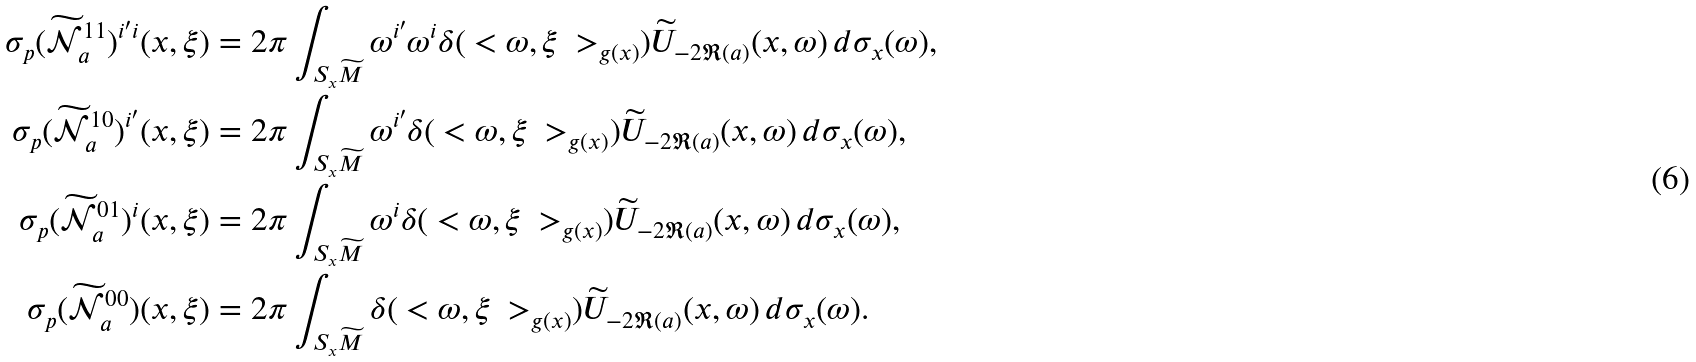Convert formula to latex. <formula><loc_0><loc_0><loc_500><loc_500>\sigma _ { p } ( \widetilde { \mathcal { N } } _ { a } ^ { 1 1 } ) ^ { i ^ { \prime } i } ( x , \xi ) & = 2 \pi \int _ { S _ { x } \widetilde { M } } \omega ^ { i ^ { \prime } } \omega ^ { i } \delta ( \ < \omega , \xi \ > _ { g ( x ) } ) \widetilde { U } _ { - 2 \Re ( a ) } ( x , \omega ) \, d \sigma _ { x } ( \omega ) , \\ \sigma _ { p } ( \widetilde { \mathcal { N } } _ { a } ^ { 1 0 } ) ^ { i ^ { \prime } } ( x , \xi ) & = 2 \pi \int _ { S _ { x } \widetilde { M } } \omega ^ { i ^ { \prime } } \delta ( \ < \omega , \xi \ > _ { g ( x ) } ) \widetilde { U } _ { - 2 \Re ( a ) } ( x , \omega ) \, d \sigma _ { x } ( \omega ) , \\ \sigma _ { p } ( \widetilde { \mathcal { N } } _ { a } ^ { 0 1 } ) ^ { i } ( x , \xi ) & = 2 \pi \int _ { S _ { x } \widetilde { M } } \omega ^ { i } \delta ( \ < \omega , \xi \ > _ { g ( x ) } ) \widetilde { U } _ { - 2 \Re ( a ) } ( x , \omega ) \, d \sigma _ { x } ( \omega ) , \\ \sigma _ { p } ( \widetilde { \mathcal { N } } _ { a } ^ { 0 0 } ) ( x , \xi ) & = 2 \pi \int _ { S _ { x } \widetilde { M } } \delta ( \ < \omega , \xi \ > _ { g ( x ) } ) \widetilde { U } _ { - 2 \Re ( a ) } ( x , \omega ) \, d \sigma _ { x } ( \omega ) .</formula> 